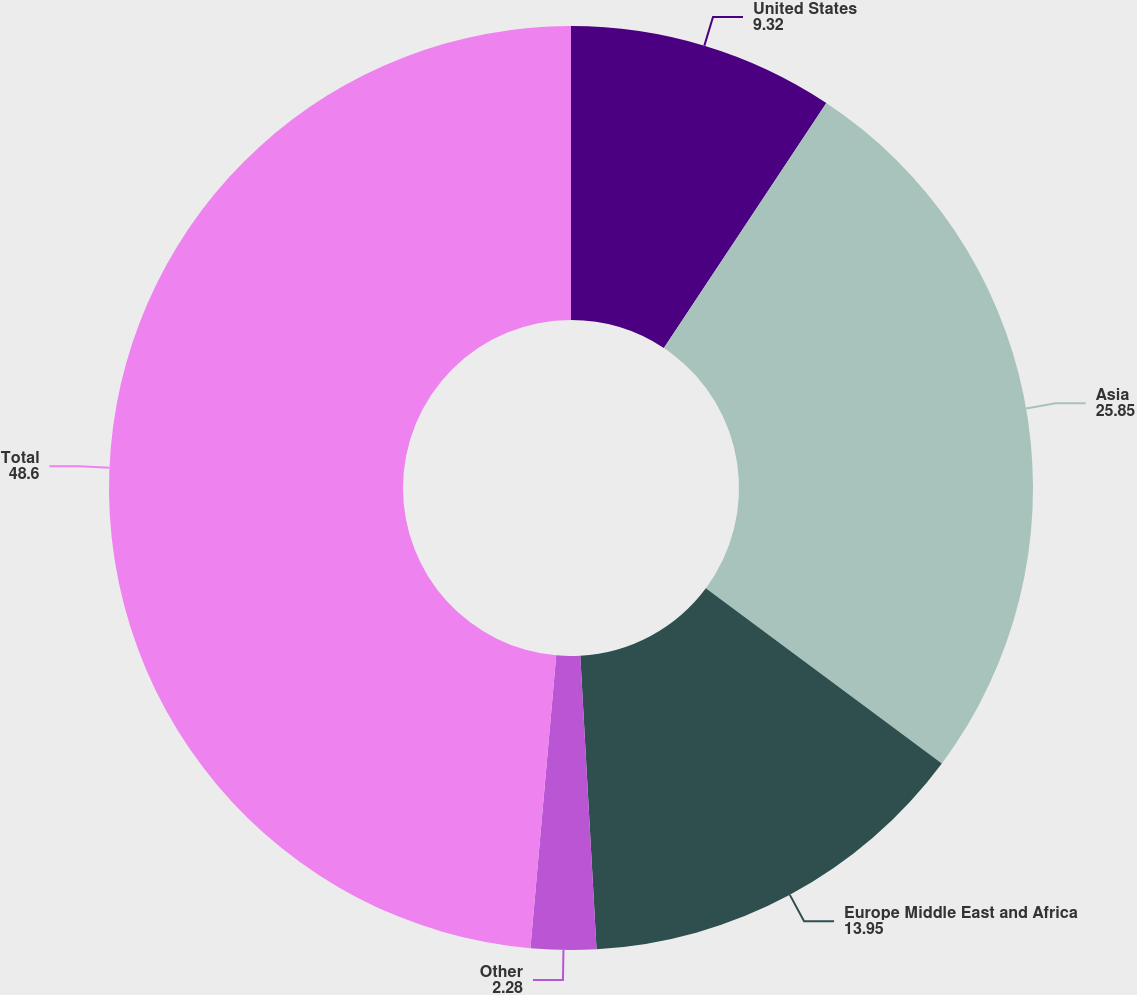<chart> <loc_0><loc_0><loc_500><loc_500><pie_chart><fcel>United States<fcel>Asia<fcel>Europe Middle East and Africa<fcel>Other<fcel>Total<nl><fcel>9.32%<fcel>25.85%<fcel>13.95%<fcel>2.28%<fcel>48.6%<nl></chart> 